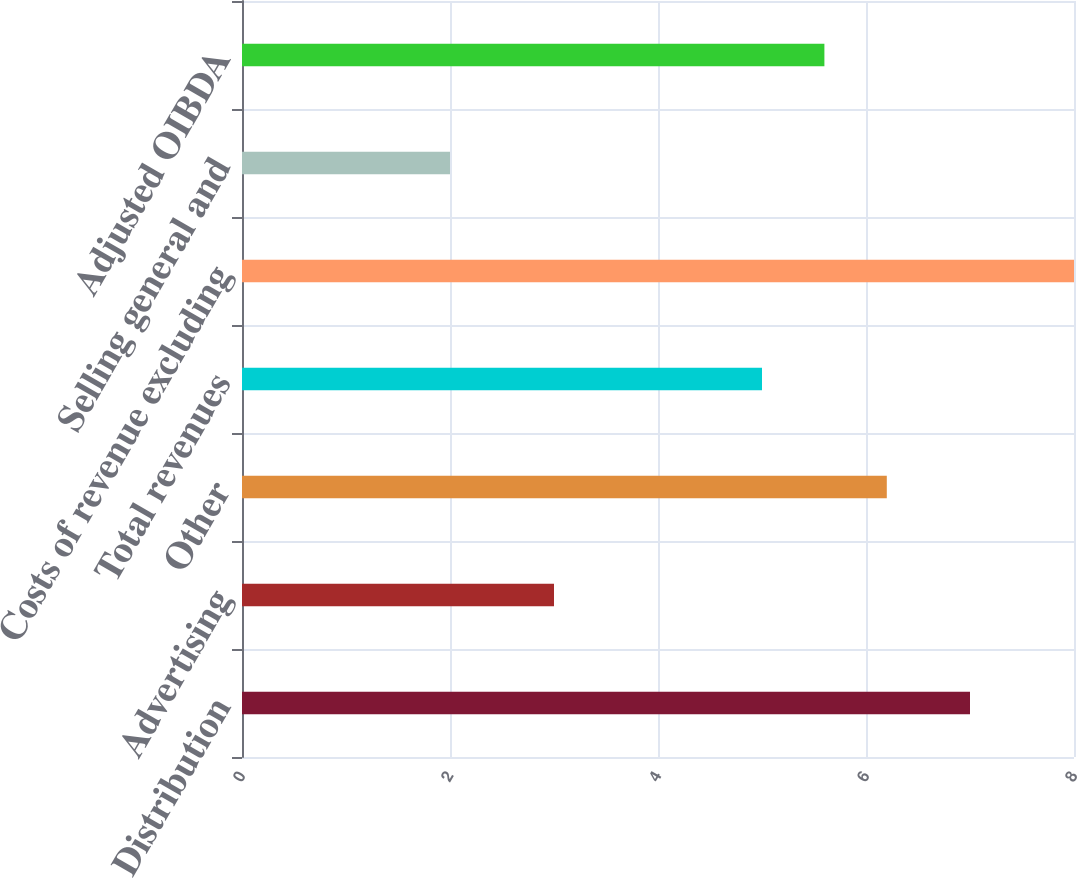<chart> <loc_0><loc_0><loc_500><loc_500><bar_chart><fcel>Distribution<fcel>Advertising<fcel>Other<fcel>Total revenues<fcel>Costs of revenue excluding<fcel>Selling general and<fcel>Adjusted OIBDA<nl><fcel>7<fcel>3<fcel>6.2<fcel>5<fcel>8<fcel>2<fcel>5.6<nl></chart> 